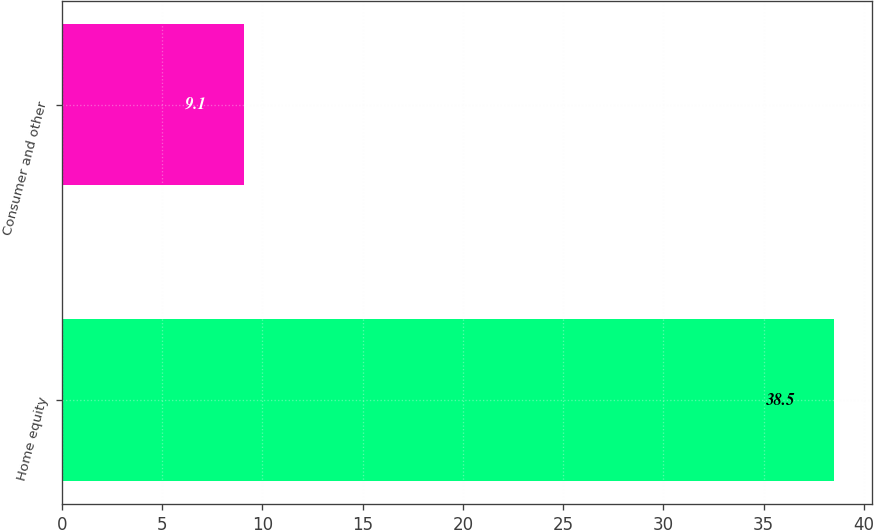Convert chart to OTSL. <chart><loc_0><loc_0><loc_500><loc_500><bar_chart><fcel>Home equity<fcel>Consumer and other<nl><fcel>38.5<fcel>9.1<nl></chart> 